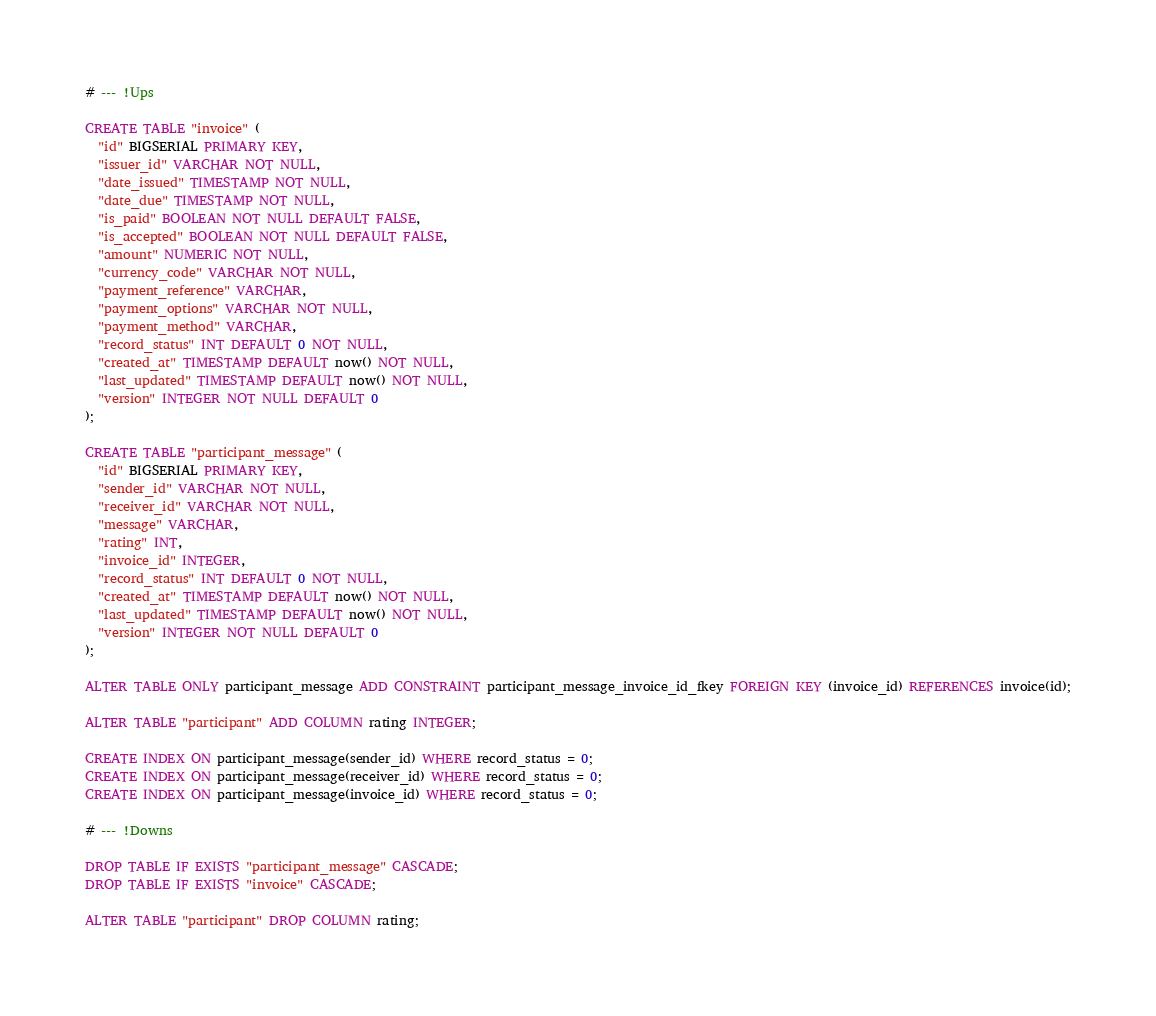<code> <loc_0><loc_0><loc_500><loc_500><_SQL_># --- !Ups

CREATE TABLE "invoice" (
  "id" BIGSERIAL PRIMARY KEY,
  "issuer_id" VARCHAR NOT NULL,
  "date_issued" TIMESTAMP NOT NULL,
  "date_due" TIMESTAMP NOT NULL,
  "is_paid" BOOLEAN NOT NULL DEFAULT FALSE,
  "is_accepted" BOOLEAN NOT NULL DEFAULT FALSE,
  "amount" NUMERIC NOT NULL,
  "currency_code" VARCHAR NOT NULL,
  "payment_reference" VARCHAR,
  "payment_options" VARCHAR NOT NULL,
  "payment_method" VARCHAR,
  "record_status" INT DEFAULT 0 NOT NULL,
  "created_at" TIMESTAMP DEFAULT now() NOT NULL,
  "last_updated" TIMESTAMP DEFAULT now() NOT NULL,
  "version" INTEGER NOT NULL DEFAULT 0
);

CREATE TABLE "participant_message" (
  "id" BIGSERIAL PRIMARY KEY,
  "sender_id" VARCHAR NOT NULL,
  "receiver_id" VARCHAR NOT NULL,
  "message" VARCHAR,
  "rating" INT,
  "invoice_id" INTEGER,
  "record_status" INT DEFAULT 0 NOT NULL,
  "created_at" TIMESTAMP DEFAULT now() NOT NULL,
  "last_updated" TIMESTAMP DEFAULT now() NOT NULL,
  "version" INTEGER NOT NULL DEFAULT 0
);

ALTER TABLE ONLY participant_message ADD CONSTRAINT participant_message_invoice_id_fkey FOREIGN KEY (invoice_id) REFERENCES invoice(id);

ALTER TABLE "participant" ADD COLUMN rating INTEGER;

CREATE INDEX ON participant_message(sender_id) WHERE record_status = 0;
CREATE INDEX ON participant_message(receiver_id) WHERE record_status = 0;
CREATE INDEX ON participant_message(invoice_id) WHERE record_status = 0;

# --- !Downs

DROP TABLE IF EXISTS "participant_message" CASCADE;
DROP TABLE IF EXISTS "invoice" CASCADE;

ALTER TABLE "participant" DROP COLUMN rating;</code> 